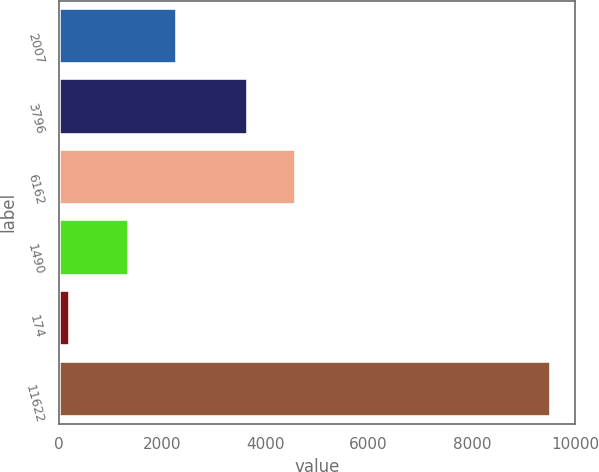Convert chart. <chart><loc_0><loc_0><loc_500><loc_500><bar_chart><fcel>2007<fcel>3796<fcel>6162<fcel>1490<fcel>174<fcel>11622<nl><fcel>2298.9<fcel>3658<fcel>4588.9<fcel>1368<fcel>219<fcel>9528<nl></chart> 